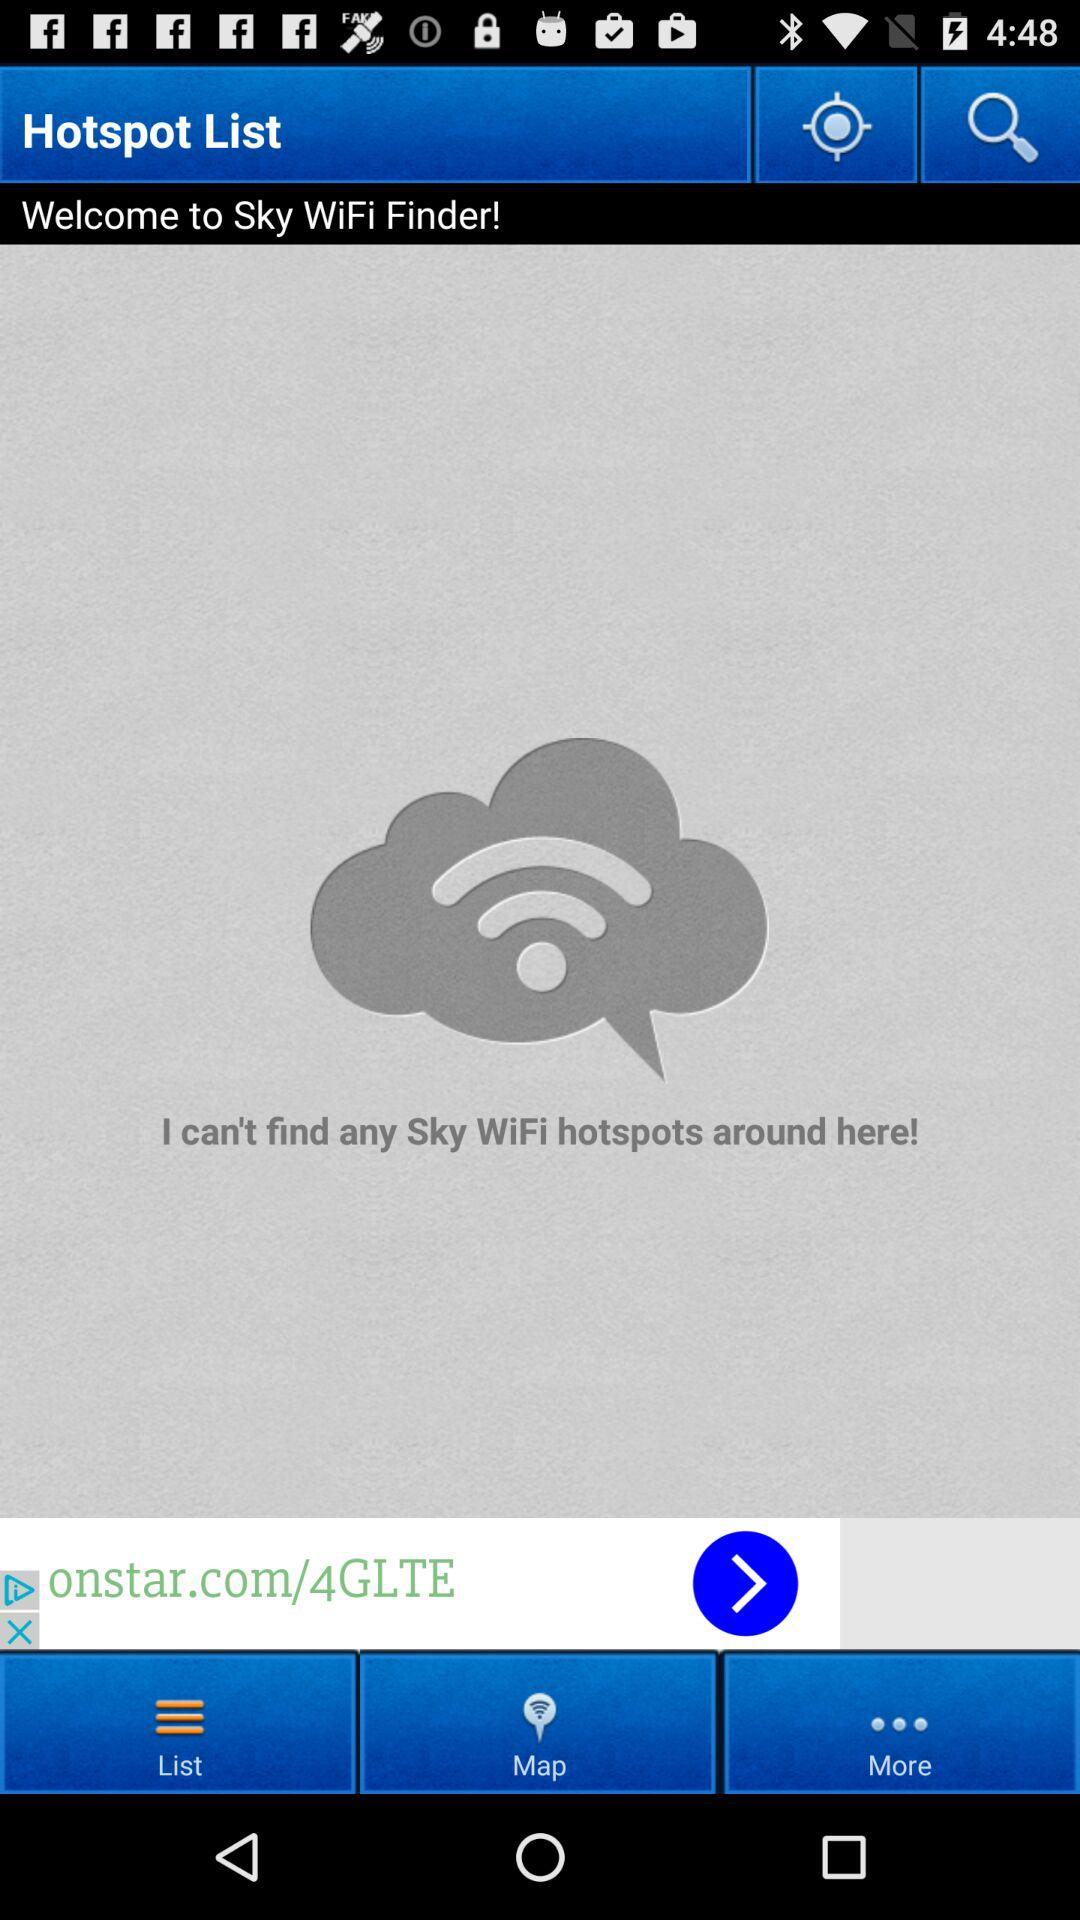What is the app name? The app name is "Sky WiFi Finder". 